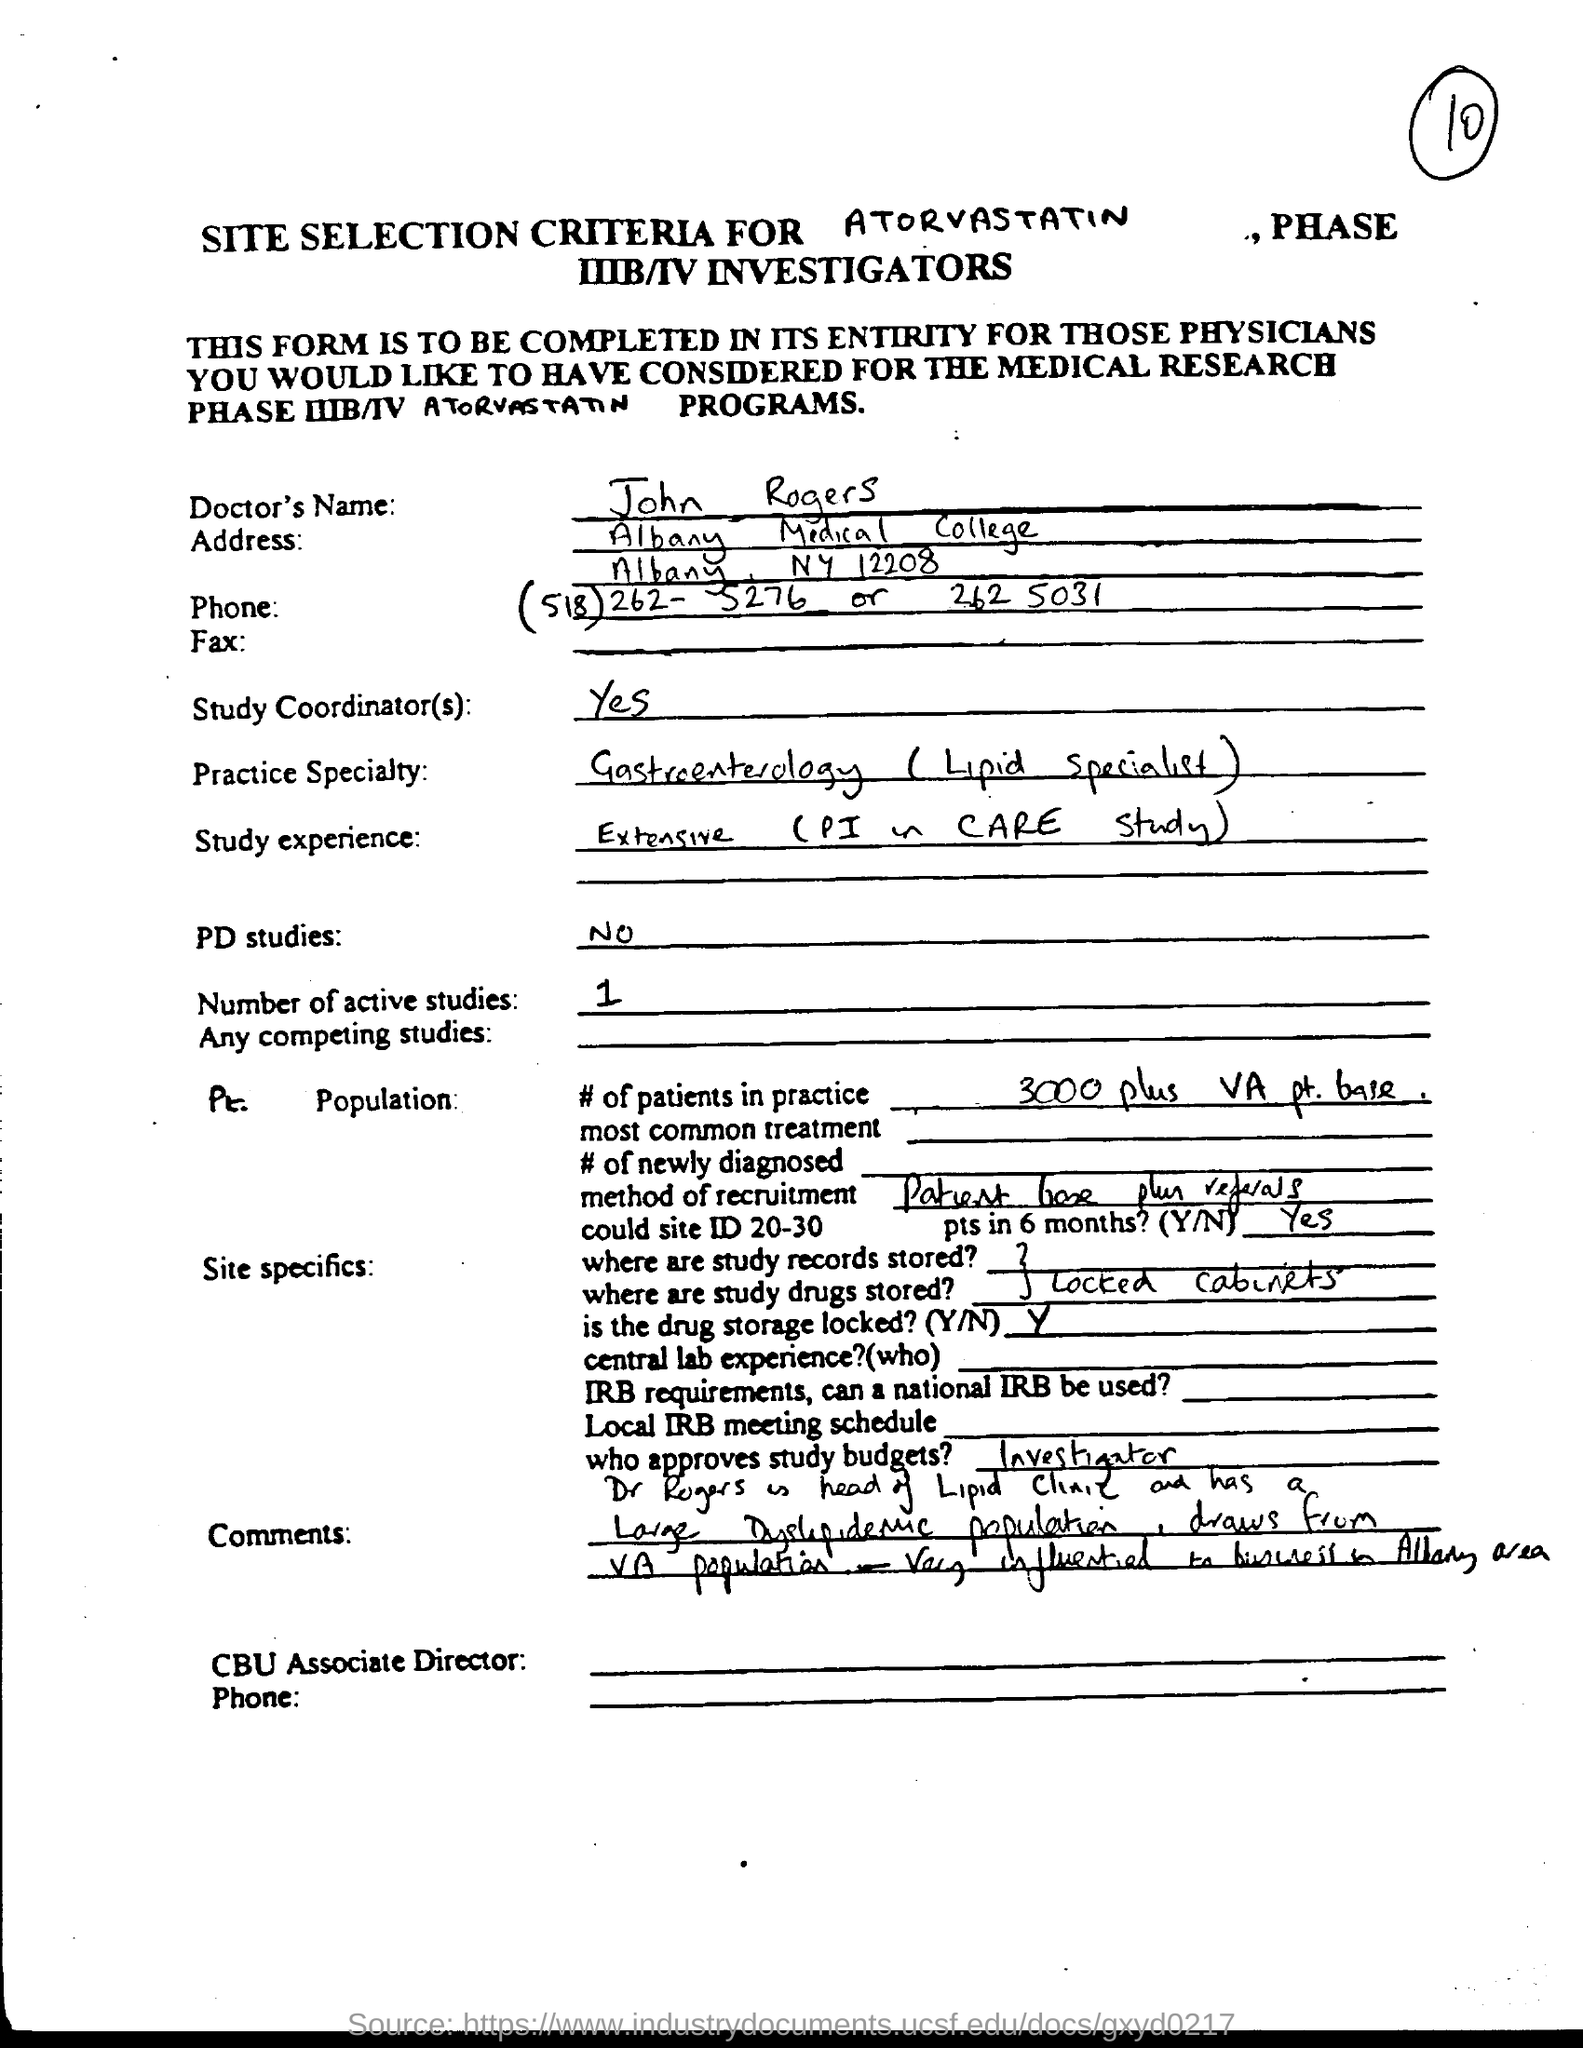What is the doctor's name ?
Provide a short and direct response. John Rogers. 